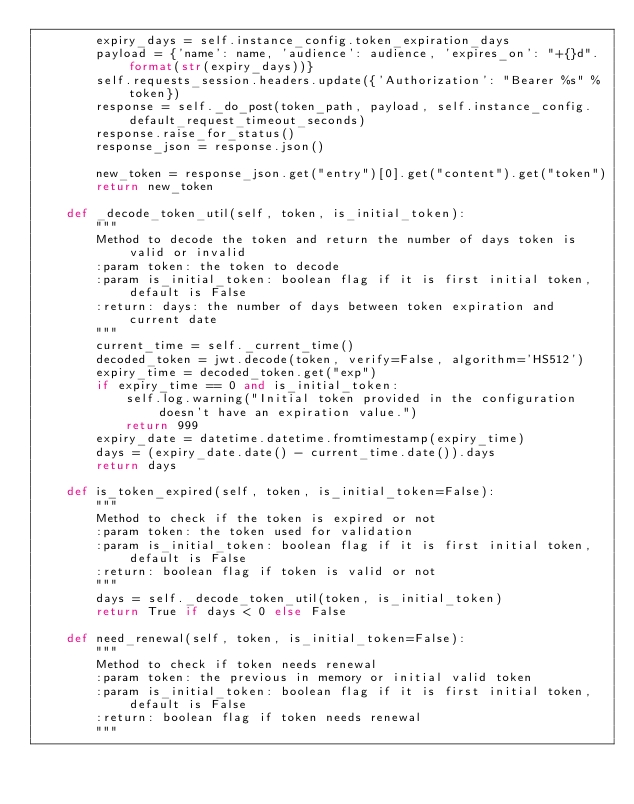Convert code to text. <code><loc_0><loc_0><loc_500><loc_500><_Python_>        expiry_days = self.instance_config.token_expiration_days
        payload = {'name': name, 'audience': audience, 'expires_on': "+{}d".format(str(expiry_days))}
        self.requests_session.headers.update({'Authorization': "Bearer %s" % token})
        response = self._do_post(token_path, payload, self.instance_config.default_request_timeout_seconds)
        response.raise_for_status()
        response_json = response.json()

        new_token = response_json.get("entry")[0].get("content").get("token")
        return new_token

    def _decode_token_util(self, token, is_initial_token):
        """
        Method to decode the token and return the number of days token is valid or invalid
        :param token: the token to decode
        :param is_initial_token: boolean flag if it is first initial token, default is False
        :return: days: the number of days between token expiration and current date
        """
        current_time = self._current_time()
        decoded_token = jwt.decode(token, verify=False, algorithm='HS512')
        expiry_time = decoded_token.get("exp")
        if expiry_time == 0 and is_initial_token:
            self.log.warning("Initial token provided in the configuration doesn't have an expiration value.")
            return 999
        expiry_date = datetime.datetime.fromtimestamp(expiry_time)
        days = (expiry_date.date() - current_time.date()).days
        return days

    def is_token_expired(self, token, is_initial_token=False):
        """
        Method to check if the token is expired or not
        :param token: the token used for validation
        :param is_initial_token: boolean flag if it is first initial token, default is False
        :return: boolean flag if token is valid or not
        """
        days = self._decode_token_util(token, is_initial_token)
        return True if days < 0 else False

    def need_renewal(self, token, is_initial_token=False):
        """
        Method to check if token needs renewal
        :param token: the previous in memory or initial valid token
        :param is_initial_token: boolean flag if it is first initial token, default is False
        :return: boolean flag if token needs renewal
        """</code> 